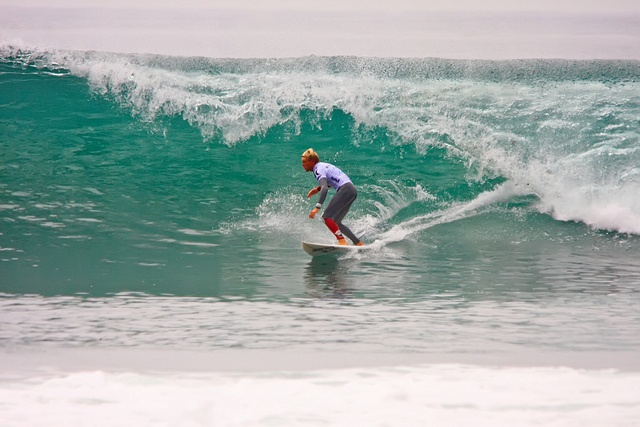Describe the objects in this image and their specific colors. I can see people in lightgray, black, gray, maroon, and lavender tones and surfboard in lightgray, gray, darkgray, and teal tones in this image. 